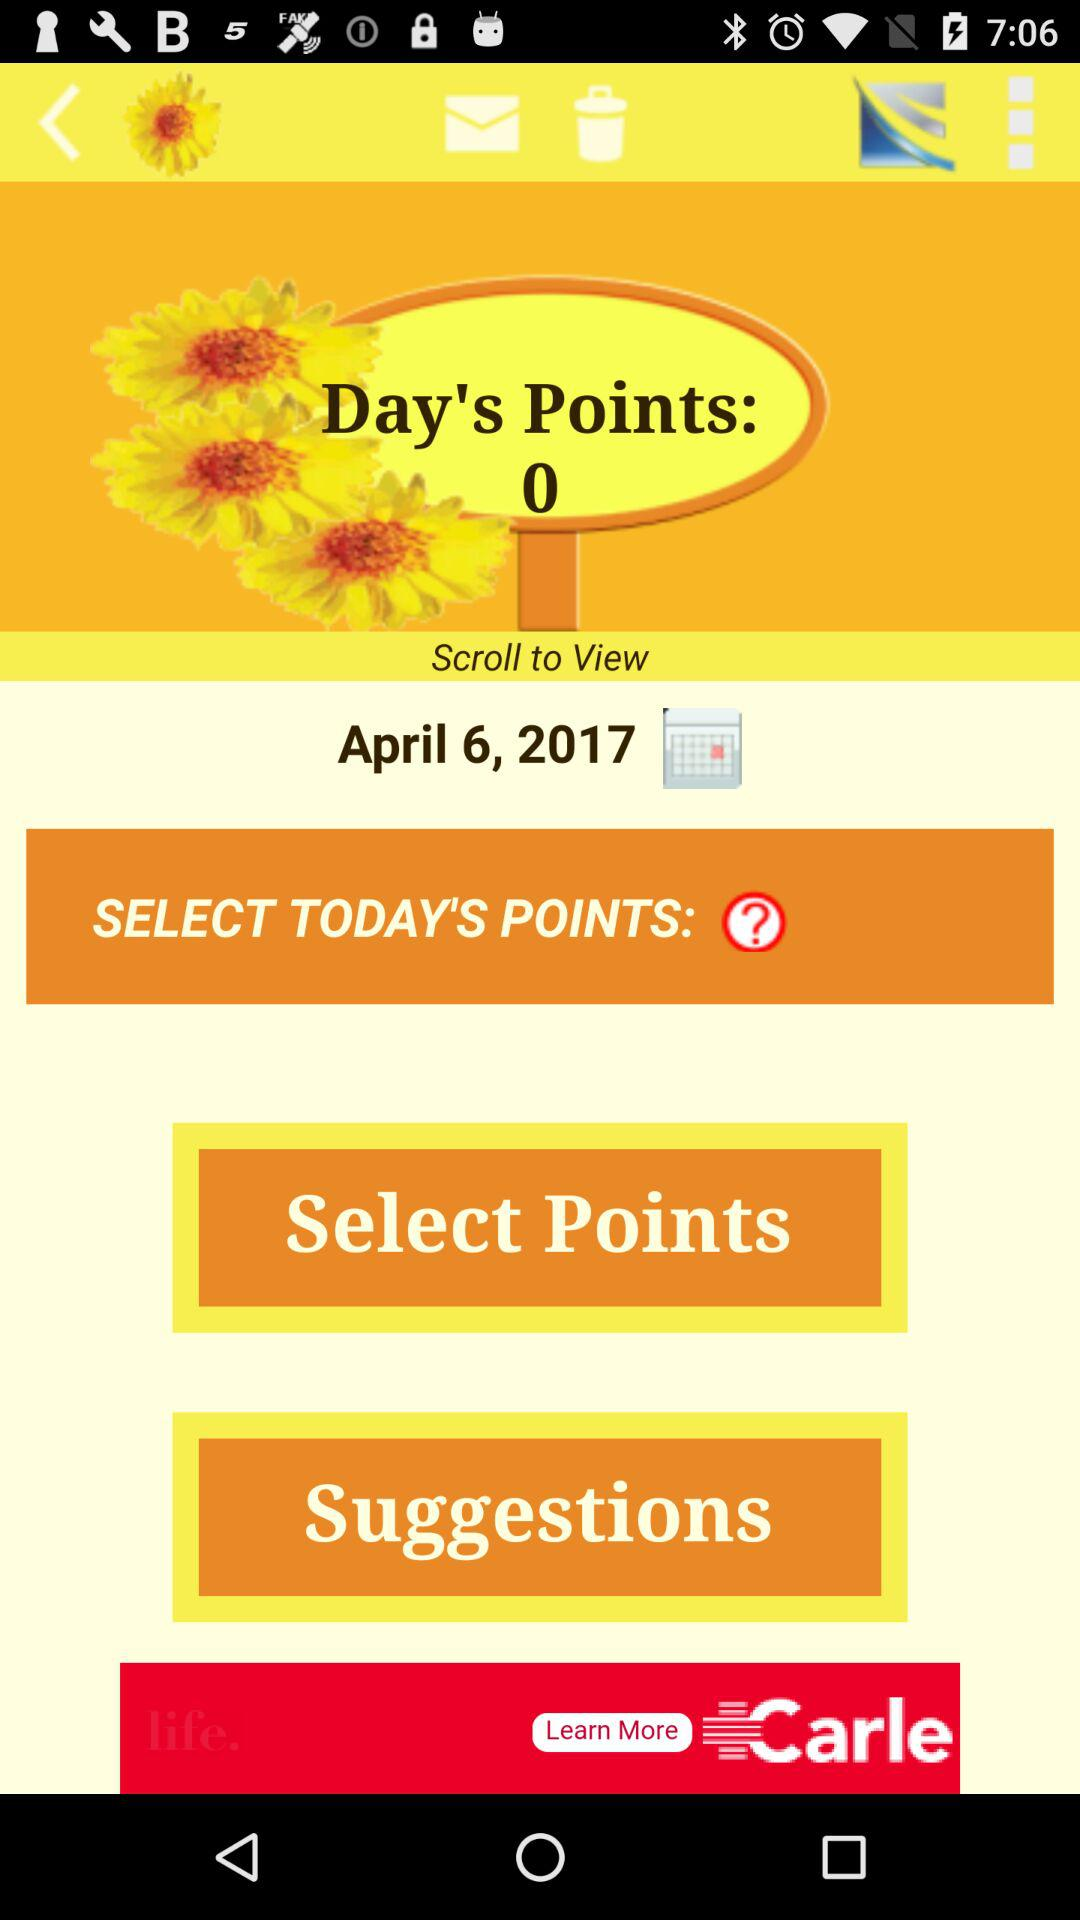What is the date? The date is April 6, 2017. 